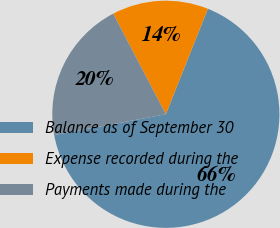Convert chart to OTSL. <chart><loc_0><loc_0><loc_500><loc_500><pie_chart><fcel>Balance as of September 30<fcel>Expense recorded during the<fcel>Payments made during the<nl><fcel>66.03%<fcel>13.71%<fcel>20.25%<nl></chart> 